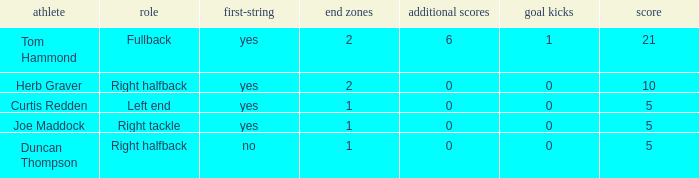Name the starter for position being left end Yes. 